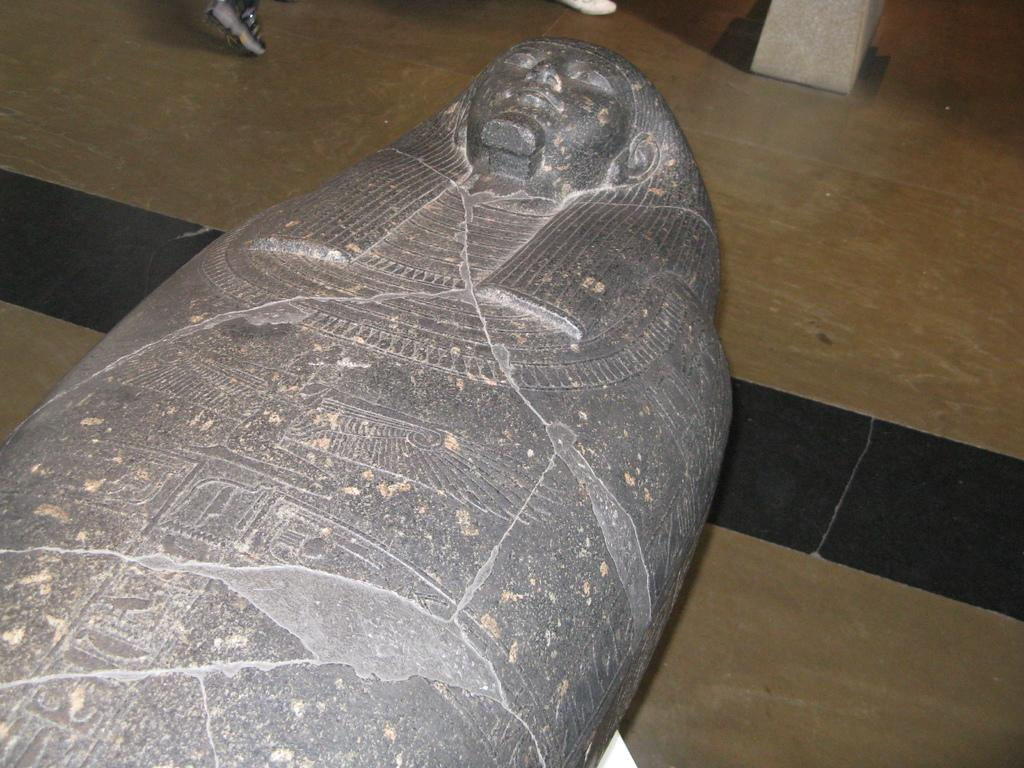What is the main subject in the image? There is a stone sculpture in the image. Can you describe the location of the stone sculpture? The stone sculpture is on the ground. What type of sea creature can be seen interacting with the stone sculpture in the image? There is no sea creature present in the image; it only features a stone sculpture on the ground. Can you see any nails being used in the construction of the stone sculpture in the image? There is no indication of nails being used in the construction of the stone sculpture in the image. 